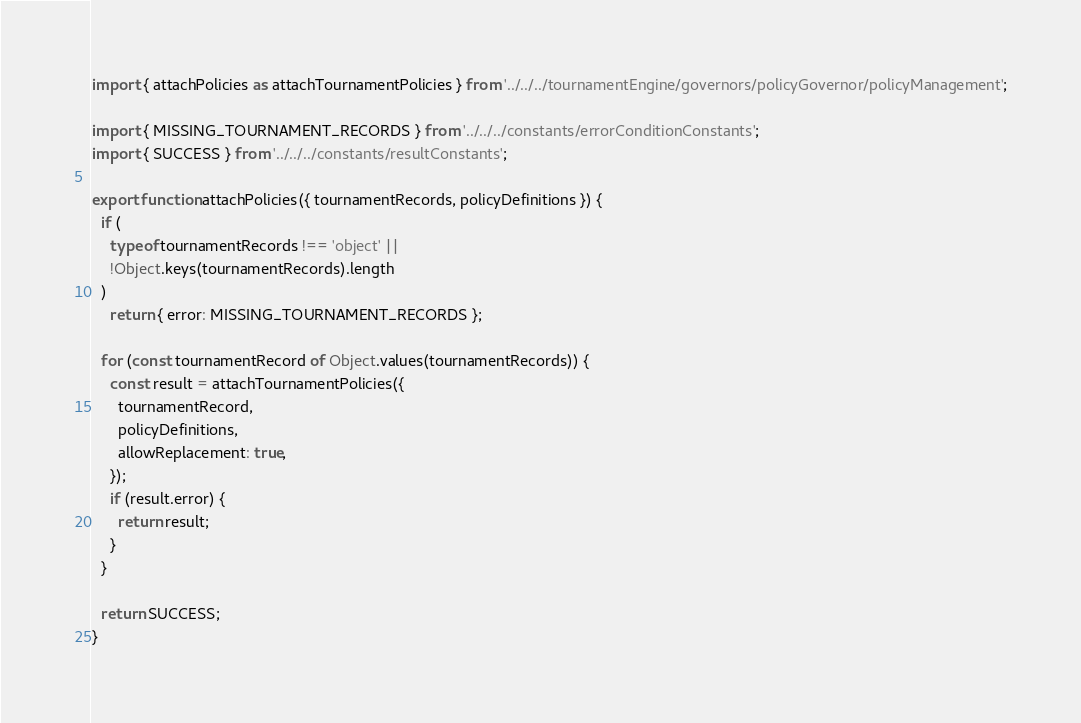<code> <loc_0><loc_0><loc_500><loc_500><_JavaScript_>import { attachPolicies as attachTournamentPolicies } from '../../../tournamentEngine/governors/policyGovernor/policyManagement';

import { MISSING_TOURNAMENT_RECORDS } from '../../../constants/errorConditionConstants';
import { SUCCESS } from '../../../constants/resultConstants';

export function attachPolicies({ tournamentRecords, policyDefinitions }) {
  if (
    typeof tournamentRecords !== 'object' ||
    !Object.keys(tournamentRecords).length
  )
    return { error: MISSING_TOURNAMENT_RECORDS };

  for (const tournamentRecord of Object.values(tournamentRecords)) {
    const result = attachTournamentPolicies({
      tournamentRecord,
      policyDefinitions,
      allowReplacement: true,
    });
    if (result.error) {
      return result;
    }
  }

  return SUCCESS;
}
</code> 